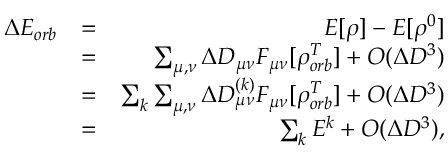<formula> <loc_0><loc_0><loc_500><loc_500>\begin{array} { r l r } { \Delta E _ { o r b } } & { = } & { E [ \rho ] - E [ \rho ^ { 0 } ] } \\ & { = } & { \sum _ { \mu , \nu } \Delta D _ { \mu \nu } F _ { \mu \nu } [ \rho _ { o r b } ^ { T } ] + O ( \Delta D ^ { 3 } ) } \\ & { = } & { \sum _ { k } \sum _ { \mu , \nu } \Delta D _ { \mu \nu } ^ { ( k ) } F _ { \mu \nu } [ \rho _ { o r b } ^ { T } ] + O ( \Delta D ^ { 3 } ) } \\ & { = } & { \sum _ { k } E ^ { k } + O ( \Delta D ^ { 3 } ) , } \end{array}</formula> 